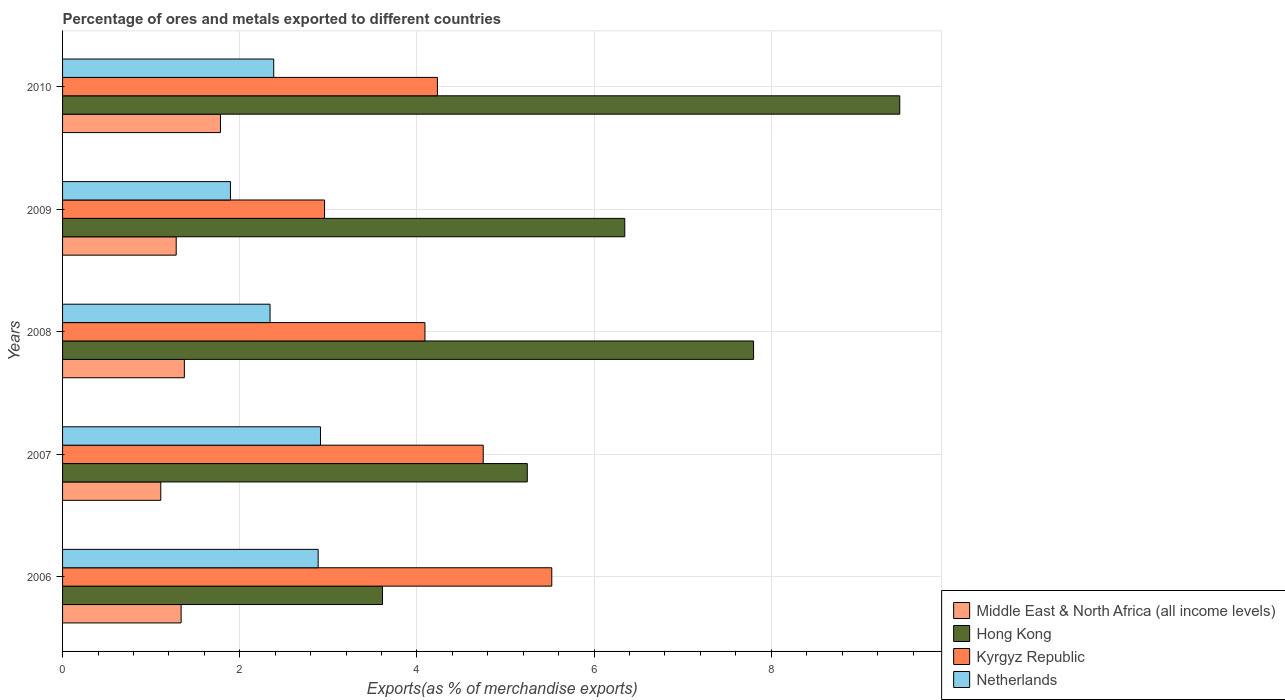How many different coloured bars are there?
Provide a short and direct response. 4. How many groups of bars are there?
Offer a very short reply. 5. What is the percentage of exports to different countries in Kyrgyz Republic in 2010?
Ensure brevity in your answer.  4.23. Across all years, what is the maximum percentage of exports to different countries in Hong Kong?
Offer a very short reply. 9.45. Across all years, what is the minimum percentage of exports to different countries in Kyrgyz Republic?
Your answer should be compact. 2.96. In which year was the percentage of exports to different countries in Middle East & North Africa (all income levels) maximum?
Keep it short and to the point. 2010. What is the total percentage of exports to different countries in Netherlands in the graph?
Offer a very short reply. 12.42. What is the difference between the percentage of exports to different countries in Netherlands in 2007 and that in 2009?
Your response must be concise. 1.02. What is the difference between the percentage of exports to different countries in Hong Kong in 2010 and the percentage of exports to different countries in Netherlands in 2006?
Keep it short and to the point. 6.57. What is the average percentage of exports to different countries in Netherlands per year?
Offer a very short reply. 2.48. In the year 2009, what is the difference between the percentage of exports to different countries in Middle East & North Africa (all income levels) and percentage of exports to different countries in Kyrgyz Republic?
Provide a short and direct response. -1.67. In how many years, is the percentage of exports to different countries in Hong Kong greater than 0.4 %?
Your answer should be very brief. 5. What is the ratio of the percentage of exports to different countries in Kyrgyz Republic in 2008 to that in 2009?
Offer a very short reply. 1.38. Is the percentage of exports to different countries in Netherlands in 2008 less than that in 2010?
Provide a succinct answer. Yes. What is the difference between the highest and the second highest percentage of exports to different countries in Middle East & North Africa (all income levels)?
Your answer should be compact. 0.41. What is the difference between the highest and the lowest percentage of exports to different countries in Hong Kong?
Offer a very short reply. 5.84. What does the 3rd bar from the top in 2009 represents?
Keep it short and to the point. Hong Kong. What does the 3rd bar from the bottom in 2008 represents?
Make the answer very short. Kyrgyz Republic. Is it the case that in every year, the sum of the percentage of exports to different countries in Netherlands and percentage of exports to different countries in Hong Kong is greater than the percentage of exports to different countries in Middle East & North Africa (all income levels)?
Your answer should be very brief. Yes. How many bars are there?
Provide a short and direct response. 20. Are all the bars in the graph horizontal?
Offer a terse response. Yes. How many years are there in the graph?
Keep it short and to the point. 5. Are the values on the major ticks of X-axis written in scientific E-notation?
Give a very brief answer. No. Does the graph contain any zero values?
Offer a terse response. No. How many legend labels are there?
Provide a succinct answer. 4. How are the legend labels stacked?
Make the answer very short. Vertical. What is the title of the graph?
Ensure brevity in your answer.  Percentage of ores and metals exported to different countries. Does "Tonga" appear as one of the legend labels in the graph?
Keep it short and to the point. No. What is the label or title of the X-axis?
Provide a succinct answer. Exports(as % of merchandise exports). What is the label or title of the Y-axis?
Your answer should be very brief. Years. What is the Exports(as % of merchandise exports) in Middle East & North Africa (all income levels) in 2006?
Offer a terse response. 1.34. What is the Exports(as % of merchandise exports) of Hong Kong in 2006?
Offer a terse response. 3.61. What is the Exports(as % of merchandise exports) of Kyrgyz Republic in 2006?
Your answer should be compact. 5.52. What is the Exports(as % of merchandise exports) of Netherlands in 2006?
Keep it short and to the point. 2.89. What is the Exports(as % of merchandise exports) of Middle East & North Africa (all income levels) in 2007?
Offer a terse response. 1.11. What is the Exports(as % of merchandise exports) in Hong Kong in 2007?
Your answer should be compact. 5.25. What is the Exports(as % of merchandise exports) of Kyrgyz Republic in 2007?
Provide a short and direct response. 4.75. What is the Exports(as % of merchandise exports) of Netherlands in 2007?
Ensure brevity in your answer.  2.91. What is the Exports(as % of merchandise exports) in Middle East & North Africa (all income levels) in 2008?
Provide a succinct answer. 1.37. What is the Exports(as % of merchandise exports) in Hong Kong in 2008?
Keep it short and to the point. 7.8. What is the Exports(as % of merchandise exports) of Kyrgyz Republic in 2008?
Your answer should be compact. 4.09. What is the Exports(as % of merchandise exports) in Netherlands in 2008?
Provide a succinct answer. 2.34. What is the Exports(as % of merchandise exports) of Middle East & North Africa (all income levels) in 2009?
Ensure brevity in your answer.  1.28. What is the Exports(as % of merchandise exports) of Hong Kong in 2009?
Your response must be concise. 6.35. What is the Exports(as % of merchandise exports) in Kyrgyz Republic in 2009?
Keep it short and to the point. 2.96. What is the Exports(as % of merchandise exports) in Netherlands in 2009?
Ensure brevity in your answer.  1.89. What is the Exports(as % of merchandise exports) of Middle East & North Africa (all income levels) in 2010?
Your answer should be compact. 1.78. What is the Exports(as % of merchandise exports) of Hong Kong in 2010?
Offer a terse response. 9.45. What is the Exports(as % of merchandise exports) in Kyrgyz Republic in 2010?
Your response must be concise. 4.23. What is the Exports(as % of merchandise exports) of Netherlands in 2010?
Provide a short and direct response. 2.38. Across all years, what is the maximum Exports(as % of merchandise exports) of Middle East & North Africa (all income levels)?
Your response must be concise. 1.78. Across all years, what is the maximum Exports(as % of merchandise exports) in Hong Kong?
Keep it short and to the point. 9.45. Across all years, what is the maximum Exports(as % of merchandise exports) in Kyrgyz Republic?
Give a very brief answer. 5.52. Across all years, what is the maximum Exports(as % of merchandise exports) of Netherlands?
Provide a succinct answer. 2.91. Across all years, what is the minimum Exports(as % of merchandise exports) of Middle East & North Africa (all income levels)?
Provide a succinct answer. 1.11. Across all years, what is the minimum Exports(as % of merchandise exports) of Hong Kong?
Your answer should be very brief. 3.61. Across all years, what is the minimum Exports(as % of merchandise exports) of Kyrgyz Republic?
Ensure brevity in your answer.  2.96. Across all years, what is the minimum Exports(as % of merchandise exports) in Netherlands?
Offer a very short reply. 1.89. What is the total Exports(as % of merchandise exports) of Middle East & North Africa (all income levels) in the graph?
Offer a very short reply. 6.89. What is the total Exports(as % of merchandise exports) in Hong Kong in the graph?
Your response must be concise. 32.45. What is the total Exports(as % of merchandise exports) of Kyrgyz Republic in the graph?
Provide a succinct answer. 21.55. What is the total Exports(as % of merchandise exports) of Netherlands in the graph?
Ensure brevity in your answer.  12.42. What is the difference between the Exports(as % of merchandise exports) of Middle East & North Africa (all income levels) in 2006 and that in 2007?
Provide a succinct answer. 0.23. What is the difference between the Exports(as % of merchandise exports) in Hong Kong in 2006 and that in 2007?
Provide a short and direct response. -1.63. What is the difference between the Exports(as % of merchandise exports) of Kyrgyz Republic in 2006 and that in 2007?
Your answer should be compact. 0.77. What is the difference between the Exports(as % of merchandise exports) in Netherlands in 2006 and that in 2007?
Your response must be concise. -0.03. What is the difference between the Exports(as % of merchandise exports) of Middle East & North Africa (all income levels) in 2006 and that in 2008?
Provide a succinct answer. -0.04. What is the difference between the Exports(as % of merchandise exports) in Hong Kong in 2006 and that in 2008?
Ensure brevity in your answer.  -4.19. What is the difference between the Exports(as % of merchandise exports) of Kyrgyz Republic in 2006 and that in 2008?
Offer a terse response. 1.43. What is the difference between the Exports(as % of merchandise exports) in Netherlands in 2006 and that in 2008?
Keep it short and to the point. 0.54. What is the difference between the Exports(as % of merchandise exports) in Middle East & North Africa (all income levels) in 2006 and that in 2009?
Your response must be concise. 0.06. What is the difference between the Exports(as % of merchandise exports) in Hong Kong in 2006 and that in 2009?
Keep it short and to the point. -2.73. What is the difference between the Exports(as % of merchandise exports) of Kyrgyz Republic in 2006 and that in 2009?
Your answer should be compact. 2.56. What is the difference between the Exports(as % of merchandise exports) in Netherlands in 2006 and that in 2009?
Ensure brevity in your answer.  0.99. What is the difference between the Exports(as % of merchandise exports) of Middle East & North Africa (all income levels) in 2006 and that in 2010?
Keep it short and to the point. -0.44. What is the difference between the Exports(as % of merchandise exports) of Hong Kong in 2006 and that in 2010?
Give a very brief answer. -5.84. What is the difference between the Exports(as % of merchandise exports) in Kyrgyz Republic in 2006 and that in 2010?
Provide a succinct answer. 1.29. What is the difference between the Exports(as % of merchandise exports) in Netherlands in 2006 and that in 2010?
Provide a succinct answer. 0.5. What is the difference between the Exports(as % of merchandise exports) of Middle East & North Africa (all income levels) in 2007 and that in 2008?
Your response must be concise. -0.27. What is the difference between the Exports(as % of merchandise exports) in Hong Kong in 2007 and that in 2008?
Provide a short and direct response. -2.55. What is the difference between the Exports(as % of merchandise exports) of Kyrgyz Republic in 2007 and that in 2008?
Offer a very short reply. 0.66. What is the difference between the Exports(as % of merchandise exports) in Netherlands in 2007 and that in 2008?
Make the answer very short. 0.57. What is the difference between the Exports(as % of merchandise exports) of Middle East & North Africa (all income levels) in 2007 and that in 2009?
Offer a terse response. -0.17. What is the difference between the Exports(as % of merchandise exports) in Hong Kong in 2007 and that in 2009?
Provide a succinct answer. -1.1. What is the difference between the Exports(as % of merchandise exports) in Kyrgyz Republic in 2007 and that in 2009?
Make the answer very short. 1.79. What is the difference between the Exports(as % of merchandise exports) of Netherlands in 2007 and that in 2009?
Ensure brevity in your answer.  1.02. What is the difference between the Exports(as % of merchandise exports) of Middle East & North Africa (all income levels) in 2007 and that in 2010?
Offer a very short reply. -0.67. What is the difference between the Exports(as % of merchandise exports) in Hong Kong in 2007 and that in 2010?
Your response must be concise. -4.2. What is the difference between the Exports(as % of merchandise exports) in Kyrgyz Republic in 2007 and that in 2010?
Your answer should be very brief. 0.52. What is the difference between the Exports(as % of merchandise exports) of Netherlands in 2007 and that in 2010?
Your response must be concise. 0.53. What is the difference between the Exports(as % of merchandise exports) in Middle East & North Africa (all income levels) in 2008 and that in 2009?
Ensure brevity in your answer.  0.09. What is the difference between the Exports(as % of merchandise exports) in Hong Kong in 2008 and that in 2009?
Keep it short and to the point. 1.45. What is the difference between the Exports(as % of merchandise exports) of Kyrgyz Republic in 2008 and that in 2009?
Provide a succinct answer. 1.13. What is the difference between the Exports(as % of merchandise exports) of Netherlands in 2008 and that in 2009?
Make the answer very short. 0.45. What is the difference between the Exports(as % of merchandise exports) of Middle East & North Africa (all income levels) in 2008 and that in 2010?
Offer a terse response. -0.41. What is the difference between the Exports(as % of merchandise exports) of Hong Kong in 2008 and that in 2010?
Your answer should be compact. -1.65. What is the difference between the Exports(as % of merchandise exports) in Kyrgyz Republic in 2008 and that in 2010?
Provide a short and direct response. -0.14. What is the difference between the Exports(as % of merchandise exports) of Netherlands in 2008 and that in 2010?
Your answer should be very brief. -0.04. What is the difference between the Exports(as % of merchandise exports) of Middle East & North Africa (all income levels) in 2009 and that in 2010?
Your answer should be very brief. -0.5. What is the difference between the Exports(as % of merchandise exports) in Hong Kong in 2009 and that in 2010?
Your answer should be compact. -3.1. What is the difference between the Exports(as % of merchandise exports) in Kyrgyz Republic in 2009 and that in 2010?
Make the answer very short. -1.27. What is the difference between the Exports(as % of merchandise exports) in Netherlands in 2009 and that in 2010?
Your answer should be very brief. -0.49. What is the difference between the Exports(as % of merchandise exports) in Middle East & North Africa (all income levels) in 2006 and the Exports(as % of merchandise exports) in Hong Kong in 2007?
Give a very brief answer. -3.91. What is the difference between the Exports(as % of merchandise exports) in Middle East & North Africa (all income levels) in 2006 and the Exports(as % of merchandise exports) in Kyrgyz Republic in 2007?
Keep it short and to the point. -3.41. What is the difference between the Exports(as % of merchandise exports) of Middle East & North Africa (all income levels) in 2006 and the Exports(as % of merchandise exports) of Netherlands in 2007?
Your response must be concise. -1.57. What is the difference between the Exports(as % of merchandise exports) of Hong Kong in 2006 and the Exports(as % of merchandise exports) of Kyrgyz Republic in 2007?
Offer a terse response. -1.14. What is the difference between the Exports(as % of merchandise exports) of Hong Kong in 2006 and the Exports(as % of merchandise exports) of Netherlands in 2007?
Make the answer very short. 0.7. What is the difference between the Exports(as % of merchandise exports) in Kyrgyz Republic in 2006 and the Exports(as % of merchandise exports) in Netherlands in 2007?
Your answer should be very brief. 2.61. What is the difference between the Exports(as % of merchandise exports) in Middle East & North Africa (all income levels) in 2006 and the Exports(as % of merchandise exports) in Hong Kong in 2008?
Your answer should be very brief. -6.46. What is the difference between the Exports(as % of merchandise exports) in Middle East & North Africa (all income levels) in 2006 and the Exports(as % of merchandise exports) in Kyrgyz Republic in 2008?
Ensure brevity in your answer.  -2.75. What is the difference between the Exports(as % of merchandise exports) of Middle East & North Africa (all income levels) in 2006 and the Exports(as % of merchandise exports) of Netherlands in 2008?
Your answer should be very brief. -1. What is the difference between the Exports(as % of merchandise exports) in Hong Kong in 2006 and the Exports(as % of merchandise exports) in Kyrgyz Republic in 2008?
Keep it short and to the point. -0.48. What is the difference between the Exports(as % of merchandise exports) of Hong Kong in 2006 and the Exports(as % of merchandise exports) of Netherlands in 2008?
Your answer should be very brief. 1.27. What is the difference between the Exports(as % of merchandise exports) of Kyrgyz Republic in 2006 and the Exports(as % of merchandise exports) of Netherlands in 2008?
Provide a short and direct response. 3.18. What is the difference between the Exports(as % of merchandise exports) of Middle East & North Africa (all income levels) in 2006 and the Exports(as % of merchandise exports) of Hong Kong in 2009?
Give a very brief answer. -5.01. What is the difference between the Exports(as % of merchandise exports) of Middle East & North Africa (all income levels) in 2006 and the Exports(as % of merchandise exports) of Kyrgyz Republic in 2009?
Provide a short and direct response. -1.62. What is the difference between the Exports(as % of merchandise exports) of Middle East & North Africa (all income levels) in 2006 and the Exports(as % of merchandise exports) of Netherlands in 2009?
Provide a short and direct response. -0.56. What is the difference between the Exports(as % of merchandise exports) in Hong Kong in 2006 and the Exports(as % of merchandise exports) in Kyrgyz Republic in 2009?
Provide a short and direct response. 0.65. What is the difference between the Exports(as % of merchandise exports) in Hong Kong in 2006 and the Exports(as % of merchandise exports) in Netherlands in 2009?
Offer a terse response. 1.72. What is the difference between the Exports(as % of merchandise exports) in Kyrgyz Republic in 2006 and the Exports(as % of merchandise exports) in Netherlands in 2009?
Your answer should be very brief. 3.63. What is the difference between the Exports(as % of merchandise exports) of Middle East & North Africa (all income levels) in 2006 and the Exports(as % of merchandise exports) of Hong Kong in 2010?
Make the answer very short. -8.11. What is the difference between the Exports(as % of merchandise exports) of Middle East & North Africa (all income levels) in 2006 and the Exports(as % of merchandise exports) of Kyrgyz Republic in 2010?
Make the answer very short. -2.89. What is the difference between the Exports(as % of merchandise exports) in Middle East & North Africa (all income levels) in 2006 and the Exports(as % of merchandise exports) in Netherlands in 2010?
Your answer should be compact. -1.05. What is the difference between the Exports(as % of merchandise exports) in Hong Kong in 2006 and the Exports(as % of merchandise exports) in Kyrgyz Republic in 2010?
Provide a succinct answer. -0.62. What is the difference between the Exports(as % of merchandise exports) in Hong Kong in 2006 and the Exports(as % of merchandise exports) in Netherlands in 2010?
Provide a short and direct response. 1.23. What is the difference between the Exports(as % of merchandise exports) of Kyrgyz Republic in 2006 and the Exports(as % of merchandise exports) of Netherlands in 2010?
Your answer should be very brief. 3.14. What is the difference between the Exports(as % of merchandise exports) of Middle East & North Africa (all income levels) in 2007 and the Exports(as % of merchandise exports) of Hong Kong in 2008?
Keep it short and to the point. -6.69. What is the difference between the Exports(as % of merchandise exports) of Middle East & North Africa (all income levels) in 2007 and the Exports(as % of merchandise exports) of Kyrgyz Republic in 2008?
Your answer should be compact. -2.98. What is the difference between the Exports(as % of merchandise exports) in Middle East & North Africa (all income levels) in 2007 and the Exports(as % of merchandise exports) in Netherlands in 2008?
Offer a very short reply. -1.23. What is the difference between the Exports(as % of merchandise exports) of Hong Kong in 2007 and the Exports(as % of merchandise exports) of Kyrgyz Republic in 2008?
Offer a terse response. 1.16. What is the difference between the Exports(as % of merchandise exports) of Hong Kong in 2007 and the Exports(as % of merchandise exports) of Netherlands in 2008?
Your response must be concise. 2.9. What is the difference between the Exports(as % of merchandise exports) in Kyrgyz Republic in 2007 and the Exports(as % of merchandise exports) in Netherlands in 2008?
Provide a short and direct response. 2.41. What is the difference between the Exports(as % of merchandise exports) of Middle East & North Africa (all income levels) in 2007 and the Exports(as % of merchandise exports) of Hong Kong in 2009?
Make the answer very short. -5.24. What is the difference between the Exports(as % of merchandise exports) in Middle East & North Africa (all income levels) in 2007 and the Exports(as % of merchandise exports) in Kyrgyz Republic in 2009?
Your answer should be compact. -1.85. What is the difference between the Exports(as % of merchandise exports) in Middle East & North Africa (all income levels) in 2007 and the Exports(as % of merchandise exports) in Netherlands in 2009?
Make the answer very short. -0.79. What is the difference between the Exports(as % of merchandise exports) of Hong Kong in 2007 and the Exports(as % of merchandise exports) of Kyrgyz Republic in 2009?
Ensure brevity in your answer.  2.29. What is the difference between the Exports(as % of merchandise exports) of Hong Kong in 2007 and the Exports(as % of merchandise exports) of Netherlands in 2009?
Your answer should be very brief. 3.35. What is the difference between the Exports(as % of merchandise exports) in Kyrgyz Republic in 2007 and the Exports(as % of merchandise exports) in Netherlands in 2009?
Your answer should be very brief. 2.85. What is the difference between the Exports(as % of merchandise exports) of Middle East & North Africa (all income levels) in 2007 and the Exports(as % of merchandise exports) of Hong Kong in 2010?
Your answer should be very brief. -8.34. What is the difference between the Exports(as % of merchandise exports) of Middle East & North Africa (all income levels) in 2007 and the Exports(as % of merchandise exports) of Kyrgyz Republic in 2010?
Give a very brief answer. -3.12. What is the difference between the Exports(as % of merchandise exports) in Middle East & North Africa (all income levels) in 2007 and the Exports(as % of merchandise exports) in Netherlands in 2010?
Provide a short and direct response. -1.27. What is the difference between the Exports(as % of merchandise exports) of Hong Kong in 2007 and the Exports(as % of merchandise exports) of Kyrgyz Republic in 2010?
Your answer should be very brief. 1.01. What is the difference between the Exports(as % of merchandise exports) in Hong Kong in 2007 and the Exports(as % of merchandise exports) in Netherlands in 2010?
Your response must be concise. 2.86. What is the difference between the Exports(as % of merchandise exports) in Kyrgyz Republic in 2007 and the Exports(as % of merchandise exports) in Netherlands in 2010?
Offer a terse response. 2.36. What is the difference between the Exports(as % of merchandise exports) in Middle East & North Africa (all income levels) in 2008 and the Exports(as % of merchandise exports) in Hong Kong in 2009?
Your response must be concise. -4.97. What is the difference between the Exports(as % of merchandise exports) in Middle East & North Africa (all income levels) in 2008 and the Exports(as % of merchandise exports) in Kyrgyz Republic in 2009?
Offer a very short reply. -1.58. What is the difference between the Exports(as % of merchandise exports) of Middle East & North Africa (all income levels) in 2008 and the Exports(as % of merchandise exports) of Netherlands in 2009?
Your answer should be compact. -0.52. What is the difference between the Exports(as % of merchandise exports) of Hong Kong in 2008 and the Exports(as % of merchandise exports) of Kyrgyz Republic in 2009?
Give a very brief answer. 4.84. What is the difference between the Exports(as % of merchandise exports) in Hong Kong in 2008 and the Exports(as % of merchandise exports) in Netherlands in 2009?
Make the answer very short. 5.91. What is the difference between the Exports(as % of merchandise exports) in Kyrgyz Republic in 2008 and the Exports(as % of merchandise exports) in Netherlands in 2009?
Your answer should be very brief. 2.2. What is the difference between the Exports(as % of merchandise exports) in Middle East & North Africa (all income levels) in 2008 and the Exports(as % of merchandise exports) in Hong Kong in 2010?
Your answer should be very brief. -8.08. What is the difference between the Exports(as % of merchandise exports) in Middle East & North Africa (all income levels) in 2008 and the Exports(as % of merchandise exports) in Kyrgyz Republic in 2010?
Your response must be concise. -2.86. What is the difference between the Exports(as % of merchandise exports) of Middle East & North Africa (all income levels) in 2008 and the Exports(as % of merchandise exports) of Netherlands in 2010?
Ensure brevity in your answer.  -1.01. What is the difference between the Exports(as % of merchandise exports) in Hong Kong in 2008 and the Exports(as % of merchandise exports) in Kyrgyz Republic in 2010?
Your answer should be compact. 3.57. What is the difference between the Exports(as % of merchandise exports) of Hong Kong in 2008 and the Exports(as % of merchandise exports) of Netherlands in 2010?
Make the answer very short. 5.42. What is the difference between the Exports(as % of merchandise exports) in Kyrgyz Republic in 2008 and the Exports(as % of merchandise exports) in Netherlands in 2010?
Offer a very short reply. 1.71. What is the difference between the Exports(as % of merchandise exports) of Middle East & North Africa (all income levels) in 2009 and the Exports(as % of merchandise exports) of Hong Kong in 2010?
Your answer should be compact. -8.17. What is the difference between the Exports(as % of merchandise exports) in Middle East & North Africa (all income levels) in 2009 and the Exports(as % of merchandise exports) in Kyrgyz Republic in 2010?
Your response must be concise. -2.95. What is the difference between the Exports(as % of merchandise exports) in Middle East & North Africa (all income levels) in 2009 and the Exports(as % of merchandise exports) in Netherlands in 2010?
Your answer should be very brief. -1.1. What is the difference between the Exports(as % of merchandise exports) in Hong Kong in 2009 and the Exports(as % of merchandise exports) in Kyrgyz Republic in 2010?
Keep it short and to the point. 2.12. What is the difference between the Exports(as % of merchandise exports) in Hong Kong in 2009 and the Exports(as % of merchandise exports) in Netherlands in 2010?
Provide a short and direct response. 3.96. What is the difference between the Exports(as % of merchandise exports) in Kyrgyz Republic in 2009 and the Exports(as % of merchandise exports) in Netherlands in 2010?
Provide a succinct answer. 0.57. What is the average Exports(as % of merchandise exports) in Middle East & North Africa (all income levels) per year?
Your answer should be compact. 1.38. What is the average Exports(as % of merchandise exports) in Hong Kong per year?
Offer a terse response. 6.49. What is the average Exports(as % of merchandise exports) of Kyrgyz Republic per year?
Give a very brief answer. 4.31. What is the average Exports(as % of merchandise exports) of Netherlands per year?
Offer a very short reply. 2.48. In the year 2006, what is the difference between the Exports(as % of merchandise exports) in Middle East & North Africa (all income levels) and Exports(as % of merchandise exports) in Hong Kong?
Your answer should be compact. -2.27. In the year 2006, what is the difference between the Exports(as % of merchandise exports) of Middle East & North Africa (all income levels) and Exports(as % of merchandise exports) of Kyrgyz Republic?
Provide a short and direct response. -4.18. In the year 2006, what is the difference between the Exports(as % of merchandise exports) of Middle East & North Africa (all income levels) and Exports(as % of merchandise exports) of Netherlands?
Make the answer very short. -1.55. In the year 2006, what is the difference between the Exports(as % of merchandise exports) of Hong Kong and Exports(as % of merchandise exports) of Kyrgyz Republic?
Offer a terse response. -1.91. In the year 2006, what is the difference between the Exports(as % of merchandise exports) in Hong Kong and Exports(as % of merchandise exports) in Netherlands?
Offer a terse response. 0.73. In the year 2006, what is the difference between the Exports(as % of merchandise exports) in Kyrgyz Republic and Exports(as % of merchandise exports) in Netherlands?
Provide a short and direct response. 2.64. In the year 2007, what is the difference between the Exports(as % of merchandise exports) of Middle East & North Africa (all income levels) and Exports(as % of merchandise exports) of Hong Kong?
Keep it short and to the point. -4.14. In the year 2007, what is the difference between the Exports(as % of merchandise exports) in Middle East & North Africa (all income levels) and Exports(as % of merchandise exports) in Kyrgyz Republic?
Offer a terse response. -3.64. In the year 2007, what is the difference between the Exports(as % of merchandise exports) of Middle East & North Africa (all income levels) and Exports(as % of merchandise exports) of Netherlands?
Provide a short and direct response. -1.8. In the year 2007, what is the difference between the Exports(as % of merchandise exports) in Hong Kong and Exports(as % of merchandise exports) in Kyrgyz Republic?
Your response must be concise. 0.5. In the year 2007, what is the difference between the Exports(as % of merchandise exports) in Hong Kong and Exports(as % of merchandise exports) in Netherlands?
Give a very brief answer. 2.33. In the year 2007, what is the difference between the Exports(as % of merchandise exports) of Kyrgyz Republic and Exports(as % of merchandise exports) of Netherlands?
Offer a terse response. 1.84. In the year 2008, what is the difference between the Exports(as % of merchandise exports) in Middle East & North Africa (all income levels) and Exports(as % of merchandise exports) in Hong Kong?
Your answer should be very brief. -6.43. In the year 2008, what is the difference between the Exports(as % of merchandise exports) of Middle East & North Africa (all income levels) and Exports(as % of merchandise exports) of Kyrgyz Republic?
Provide a short and direct response. -2.72. In the year 2008, what is the difference between the Exports(as % of merchandise exports) in Middle East & North Africa (all income levels) and Exports(as % of merchandise exports) in Netherlands?
Your answer should be very brief. -0.97. In the year 2008, what is the difference between the Exports(as % of merchandise exports) of Hong Kong and Exports(as % of merchandise exports) of Kyrgyz Republic?
Ensure brevity in your answer.  3.71. In the year 2008, what is the difference between the Exports(as % of merchandise exports) in Hong Kong and Exports(as % of merchandise exports) in Netherlands?
Your answer should be very brief. 5.46. In the year 2008, what is the difference between the Exports(as % of merchandise exports) of Kyrgyz Republic and Exports(as % of merchandise exports) of Netherlands?
Your answer should be compact. 1.75. In the year 2009, what is the difference between the Exports(as % of merchandise exports) of Middle East & North Africa (all income levels) and Exports(as % of merchandise exports) of Hong Kong?
Provide a succinct answer. -5.06. In the year 2009, what is the difference between the Exports(as % of merchandise exports) in Middle East & North Africa (all income levels) and Exports(as % of merchandise exports) in Kyrgyz Republic?
Keep it short and to the point. -1.67. In the year 2009, what is the difference between the Exports(as % of merchandise exports) of Middle East & North Africa (all income levels) and Exports(as % of merchandise exports) of Netherlands?
Make the answer very short. -0.61. In the year 2009, what is the difference between the Exports(as % of merchandise exports) in Hong Kong and Exports(as % of merchandise exports) in Kyrgyz Republic?
Give a very brief answer. 3.39. In the year 2009, what is the difference between the Exports(as % of merchandise exports) in Hong Kong and Exports(as % of merchandise exports) in Netherlands?
Make the answer very short. 4.45. In the year 2009, what is the difference between the Exports(as % of merchandise exports) of Kyrgyz Republic and Exports(as % of merchandise exports) of Netherlands?
Keep it short and to the point. 1.06. In the year 2010, what is the difference between the Exports(as % of merchandise exports) in Middle East & North Africa (all income levels) and Exports(as % of merchandise exports) in Hong Kong?
Offer a very short reply. -7.67. In the year 2010, what is the difference between the Exports(as % of merchandise exports) in Middle East & North Africa (all income levels) and Exports(as % of merchandise exports) in Kyrgyz Republic?
Offer a terse response. -2.45. In the year 2010, what is the difference between the Exports(as % of merchandise exports) of Middle East & North Africa (all income levels) and Exports(as % of merchandise exports) of Netherlands?
Your answer should be very brief. -0.6. In the year 2010, what is the difference between the Exports(as % of merchandise exports) of Hong Kong and Exports(as % of merchandise exports) of Kyrgyz Republic?
Offer a terse response. 5.22. In the year 2010, what is the difference between the Exports(as % of merchandise exports) of Hong Kong and Exports(as % of merchandise exports) of Netherlands?
Offer a very short reply. 7.07. In the year 2010, what is the difference between the Exports(as % of merchandise exports) of Kyrgyz Republic and Exports(as % of merchandise exports) of Netherlands?
Ensure brevity in your answer.  1.85. What is the ratio of the Exports(as % of merchandise exports) of Middle East & North Africa (all income levels) in 2006 to that in 2007?
Offer a very short reply. 1.21. What is the ratio of the Exports(as % of merchandise exports) in Hong Kong in 2006 to that in 2007?
Your answer should be compact. 0.69. What is the ratio of the Exports(as % of merchandise exports) in Kyrgyz Republic in 2006 to that in 2007?
Your answer should be compact. 1.16. What is the ratio of the Exports(as % of merchandise exports) in Netherlands in 2006 to that in 2007?
Keep it short and to the point. 0.99. What is the ratio of the Exports(as % of merchandise exports) in Middle East & North Africa (all income levels) in 2006 to that in 2008?
Give a very brief answer. 0.97. What is the ratio of the Exports(as % of merchandise exports) in Hong Kong in 2006 to that in 2008?
Your answer should be compact. 0.46. What is the ratio of the Exports(as % of merchandise exports) of Kyrgyz Republic in 2006 to that in 2008?
Your response must be concise. 1.35. What is the ratio of the Exports(as % of merchandise exports) in Netherlands in 2006 to that in 2008?
Make the answer very short. 1.23. What is the ratio of the Exports(as % of merchandise exports) of Middle East & North Africa (all income levels) in 2006 to that in 2009?
Offer a very short reply. 1.04. What is the ratio of the Exports(as % of merchandise exports) in Hong Kong in 2006 to that in 2009?
Ensure brevity in your answer.  0.57. What is the ratio of the Exports(as % of merchandise exports) of Kyrgyz Republic in 2006 to that in 2009?
Ensure brevity in your answer.  1.87. What is the ratio of the Exports(as % of merchandise exports) of Netherlands in 2006 to that in 2009?
Your answer should be compact. 1.52. What is the ratio of the Exports(as % of merchandise exports) in Middle East & North Africa (all income levels) in 2006 to that in 2010?
Make the answer very short. 0.75. What is the ratio of the Exports(as % of merchandise exports) of Hong Kong in 2006 to that in 2010?
Your response must be concise. 0.38. What is the ratio of the Exports(as % of merchandise exports) of Kyrgyz Republic in 2006 to that in 2010?
Give a very brief answer. 1.31. What is the ratio of the Exports(as % of merchandise exports) of Netherlands in 2006 to that in 2010?
Ensure brevity in your answer.  1.21. What is the ratio of the Exports(as % of merchandise exports) of Middle East & North Africa (all income levels) in 2007 to that in 2008?
Ensure brevity in your answer.  0.81. What is the ratio of the Exports(as % of merchandise exports) in Hong Kong in 2007 to that in 2008?
Provide a short and direct response. 0.67. What is the ratio of the Exports(as % of merchandise exports) in Kyrgyz Republic in 2007 to that in 2008?
Give a very brief answer. 1.16. What is the ratio of the Exports(as % of merchandise exports) in Netherlands in 2007 to that in 2008?
Give a very brief answer. 1.24. What is the ratio of the Exports(as % of merchandise exports) of Middle East & North Africa (all income levels) in 2007 to that in 2009?
Keep it short and to the point. 0.86. What is the ratio of the Exports(as % of merchandise exports) in Hong Kong in 2007 to that in 2009?
Ensure brevity in your answer.  0.83. What is the ratio of the Exports(as % of merchandise exports) of Kyrgyz Republic in 2007 to that in 2009?
Keep it short and to the point. 1.61. What is the ratio of the Exports(as % of merchandise exports) of Netherlands in 2007 to that in 2009?
Your answer should be compact. 1.54. What is the ratio of the Exports(as % of merchandise exports) in Middle East & North Africa (all income levels) in 2007 to that in 2010?
Your answer should be compact. 0.62. What is the ratio of the Exports(as % of merchandise exports) of Hong Kong in 2007 to that in 2010?
Make the answer very short. 0.56. What is the ratio of the Exports(as % of merchandise exports) of Kyrgyz Republic in 2007 to that in 2010?
Keep it short and to the point. 1.12. What is the ratio of the Exports(as % of merchandise exports) in Netherlands in 2007 to that in 2010?
Ensure brevity in your answer.  1.22. What is the ratio of the Exports(as % of merchandise exports) in Middle East & North Africa (all income levels) in 2008 to that in 2009?
Offer a terse response. 1.07. What is the ratio of the Exports(as % of merchandise exports) of Hong Kong in 2008 to that in 2009?
Keep it short and to the point. 1.23. What is the ratio of the Exports(as % of merchandise exports) of Kyrgyz Republic in 2008 to that in 2009?
Your response must be concise. 1.38. What is the ratio of the Exports(as % of merchandise exports) of Netherlands in 2008 to that in 2009?
Give a very brief answer. 1.24. What is the ratio of the Exports(as % of merchandise exports) in Middle East & North Africa (all income levels) in 2008 to that in 2010?
Offer a very short reply. 0.77. What is the ratio of the Exports(as % of merchandise exports) in Hong Kong in 2008 to that in 2010?
Ensure brevity in your answer.  0.83. What is the ratio of the Exports(as % of merchandise exports) in Kyrgyz Republic in 2008 to that in 2010?
Your response must be concise. 0.97. What is the ratio of the Exports(as % of merchandise exports) in Netherlands in 2008 to that in 2010?
Offer a terse response. 0.98. What is the ratio of the Exports(as % of merchandise exports) in Middle East & North Africa (all income levels) in 2009 to that in 2010?
Your answer should be very brief. 0.72. What is the ratio of the Exports(as % of merchandise exports) of Hong Kong in 2009 to that in 2010?
Keep it short and to the point. 0.67. What is the ratio of the Exports(as % of merchandise exports) of Kyrgyz Republic in 2009 to that in 2010?
Make the answer very short. 0.7. What is the ratio of the Exports(as % of merchandise exports) in Netherlands in 2009 to that in 2010?
Your answer should be very brief. 0.8. What is the difference between the highest and the second highest Exports(as % of merchandise exports) in Middle East & North Africa (all income levels)?
Your answer should be very brief. 0.41. What is the difference between the highest and the second highest Exports(as % of merchandise exports) of Hong Kong?
Offer a terse response. 1.65. What is the difference between the highest and the second highest Exports(as % of merchandise exports) in Kyrgyz Republic?
Provide a short and direct response. 0.77. What is the difference between the highest and the second highest Exports(as % of merchandise exports) of Netherlands?
Ensure brevity in your answer.  0.03. What is the difference between the highest and the lowest Exports(as % of merchandise exports) of Middle East & North Africa (all income levels)?
Offer a terse response. 0.67. What is the difference between the highest and the lowest Exports(as % of merchandise exports) of Hong Kong?
Your response must be concise. 5.84. What is the difference between the highest and the lowest Exports(as % of merchandise exports) of Kyrgyz Republic?
Ensure brevity in your answer.  2.56. What is the difference between the highest and the lowest Exports(as % of merchandise exports) of Netherlands?
Your answer should be compact. 1.02. 